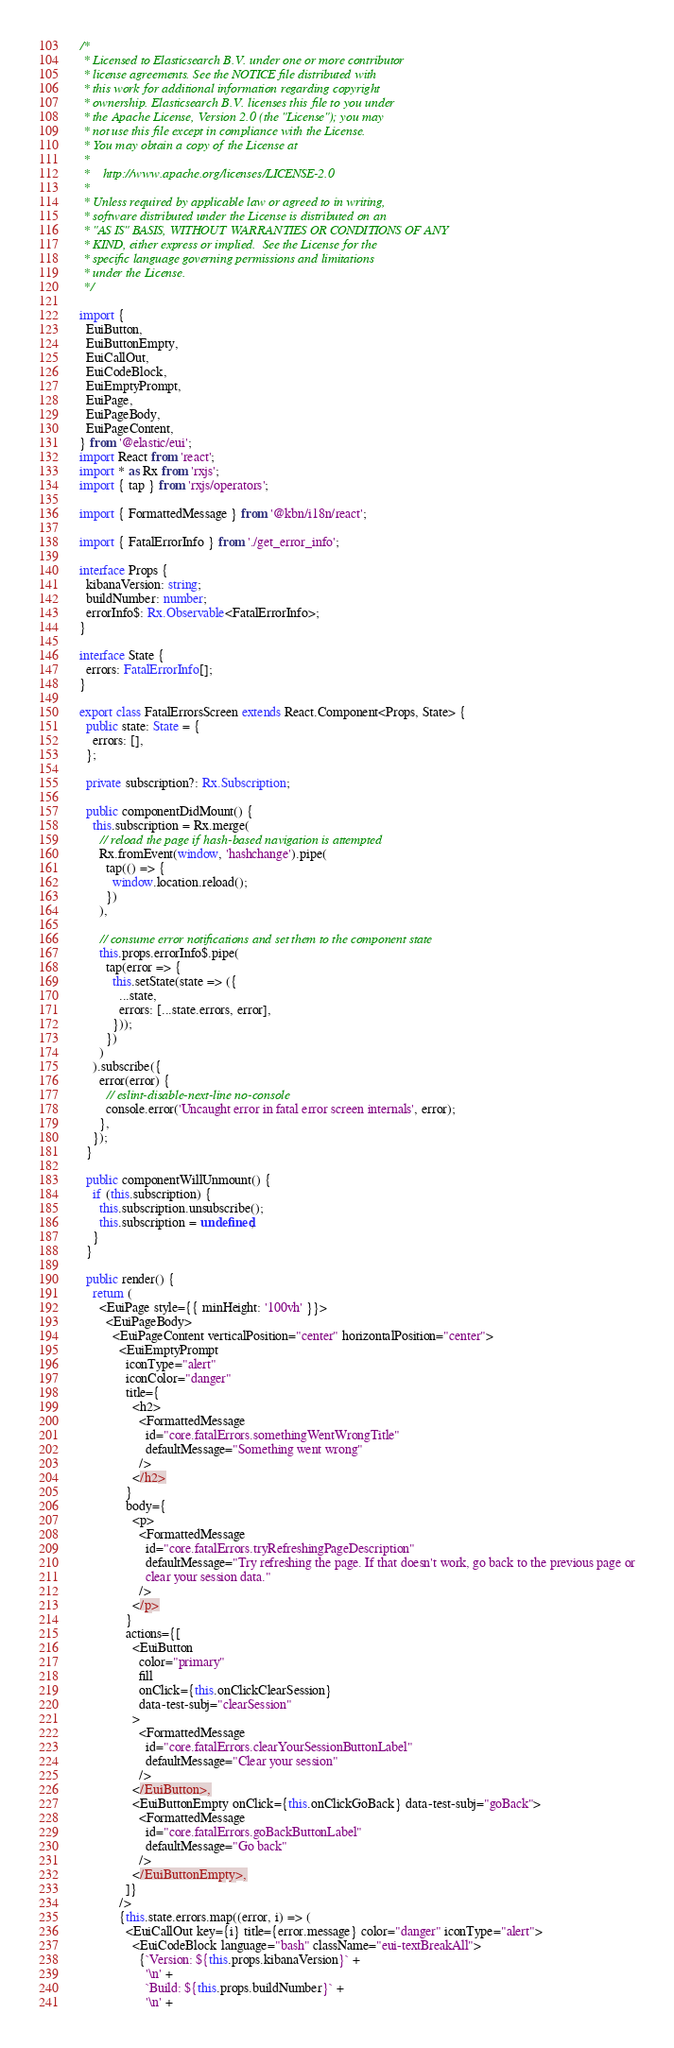<code> <loc_0><loc_0><loc_500><loc_500><_TypeScript_>/*
 * Licensed to Elasticsearch B.V. under one or more contributor
 * license agreements. See the NOTICE file distributed with
 * this work for additional information regarding copyright
 * ownership. Elasticsearch B.V. licenses this file to you under
 * the Apache License, Version 2.0 (the "License"); you may
 * not use this file except in compliance with the License.
 * You may obtain a copy of the License at
 *
 *    http://www.apache.org/licenses/LICENSE-2.0
 *
 * Unless required by applicable law or agreed to in writing,
 * software distributed under the License is distributed on an
 * "AS IS" BASIS, WITHOUT WARRANTIES OR CONDITIONS OF ANY
 * KIND, either express or implied.  See the License for the
 * specific language governing permissions and limitations
 * under the License.
 */

import {
  EuiButton,
  EuiButtonEmpty,
  EuiCallOut,
  EuiCodeBlock,
  EuiEmptyPrompt,
  EuiPage,
  EuiPageBody,
  EuiPageContent,
} from '@elastic/eui';
import React from 'react';
import * as Rx from 'rxjs';
import { tap } from 'rxjs/operators';

import { FormattedMessage } from '@kbn/i18n/react';

import { FatalErrorInfo } from './get_error_info';

interface Props {
  kibanaVersion: string;
  buildNumber: number;
  errorInfo$: Rx.Observable<FatalErrorInfo>;
}

interface State {
  errors: FatalErrorInfo[];
}

export class FatalErrorsScreen extends React.Component<Props, State> {
  public state: State = {
    errors: [],
  };

  private subscription?: Rx.Subscription;

  public componentDidMount() {
    this.subscription = Rx.merge(
      // reload the page if hash-based navigation is attempted
      Rx.fromEvent(window, 'hashchange').pipe(
        tap(() => {
          window.location.reload();
        })
      ),

      // consume error notifications and set them to the component state
      this.props.errorInfo$.pipe(
        tap(error => {
          this.setState(state => ({
            ...state,
            errors: [...state.errors, error],
          }));
        })
      )
    ).subscribe({
      error(error) {
        // eslint-disable-next-line no-console
        console.error('Uncaught error in fatal error screen internals', error);
      },
    });
  }

  public componentWillUnmount() {
    if (this.subscription) {
      this.subscription.unsubscribe();
      this.subscription = undefined;
    }
  }

  public render() {
    return (
      <EuiPage style={{ minHeight: '100vh' }}>
        <EuiPageBody>
          <EuiPageContent verticalPosition="center" horizontalPosition="center">
            <EuiEmptyPrompt
              iconType="alert"
              iconColor="danger"
              title={
                <h2>
                  <FormattedMessage
                    id="core.fatalErrors.somethingWentWrongTitle"
                    defaultMessage="Something went wrong"
                  />
                </h2>
              }
              body={
                <p>
                  <FormattedMessage
                    id="core.fatalErrors.tryRefreshingPageDescription"
                    defaultMessage="Try refreshing the page. If that doesn't work, go back to the previous page or
                    clear your session data."
                  />
                </p>
              }
              actions={[
                <EuiButton
                  color="primary"
                  fill
                  onClick={this.onClickClearSession}
                  data-test-subj="clearSession"
                >
                  <FormattedMessage
                    id="core.fatalErrors.clearYourSessionButtonLabel"
                    defaultMessage="Clear your session"
                  />
                </EuiButton>,
                <EuiButtonEmpty onClick={this.onClickGoBack} data-test-subj="goBack">
                  <FormattedMessage
                    id="core.fatalErrors.goBackButtonLabel"
                    defaultMessage="Go back"
                  />
                </EuiButtonEmpty>,
              ]}
            />
            {this.state.errors.map((error, i) => (
              <EuiCallOut key={i} title={error.message} color="danger" iconType="alert">
                <EuiCodeBlock language="bash" className="eui-textBreakAll">
                  {`Version: ${this.props.kibanaVersion}` +
                    '\n' +
                    `Build: ${this.props.buildNumber}` +
                    '\n' +</code> 